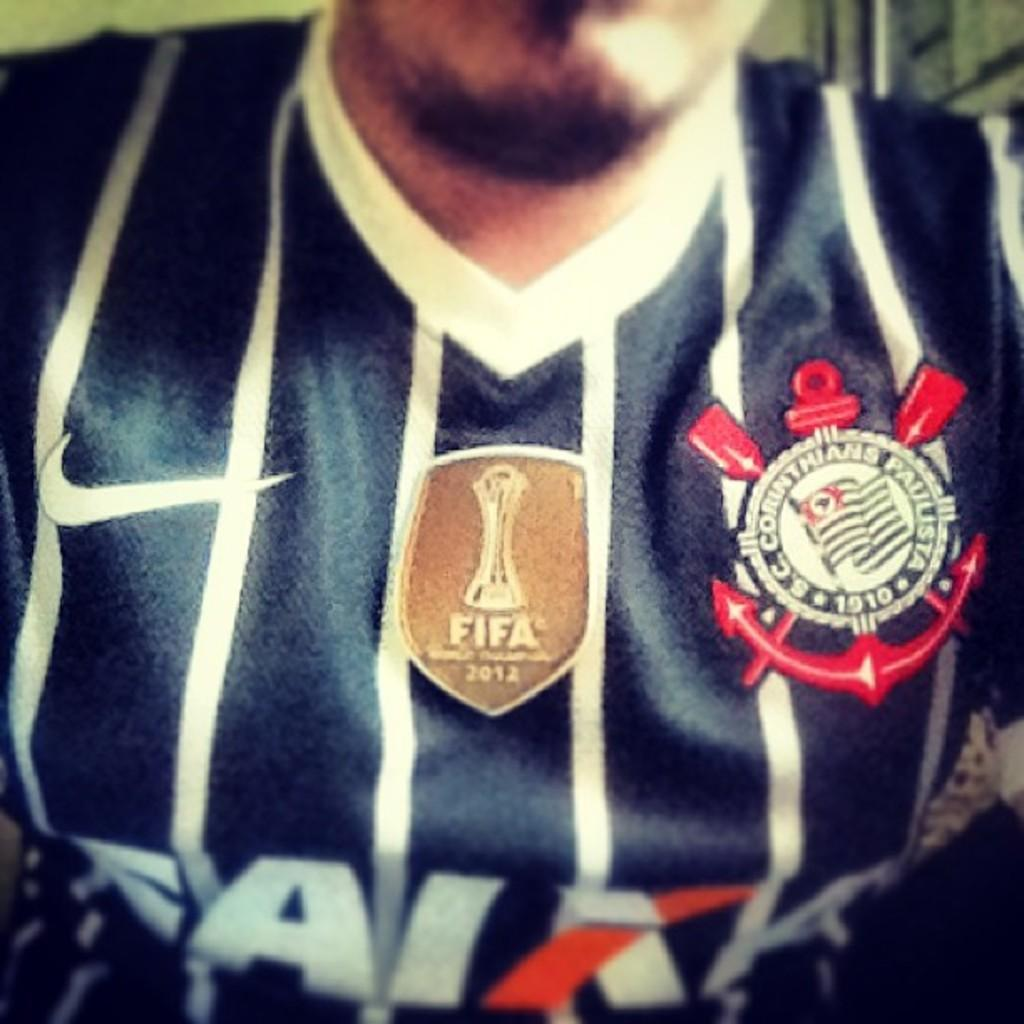<image>
Relay a brief, clear account of the picture shown. a man that is wearing a Fifa jersey that is blue 